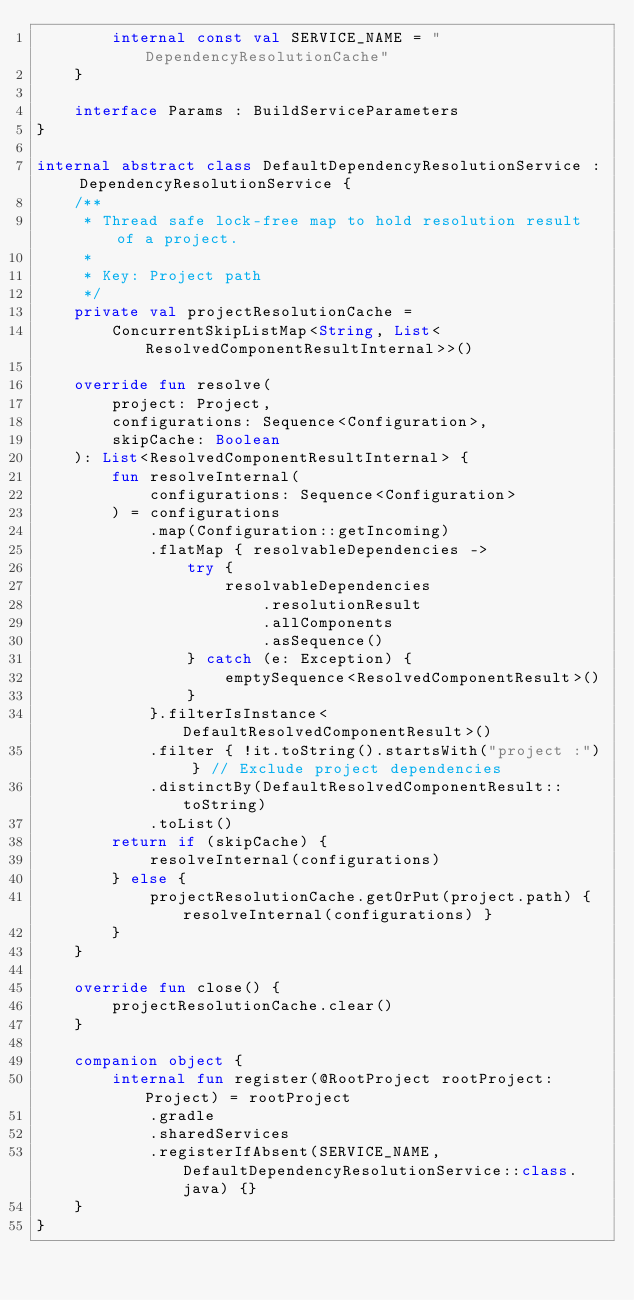<code> <loc_0><loc_0><loc_500><loc_500><_Kotlin_>        internal const val SERVICE_NAME = "DependencyResolutionCache"
    }

    interface Params : BuildServiceParameters
}

internal abstract class DefaultDependencyResolutionService : DependencyResolutionService {
    /**
     * Thread safe lock-free map to hold resolution result of a project.
     *
     * Key: Project path
     */
    private val projectResolutionCache =
        ConcurrentSkipListMap<String, List<ResolvedComponentResultInternal>>()

    override fun resolve(
        project: Project,
        configurations: Sequence<Configuration>,
        skipCache: Boolean
    ): List<ResolvedComponentResultInternal> {
        fun resolveInternal(
            configurations: Sequence<Configuration>
        ) = configurations
            .map(Configuration::getIncoming)
            .flatMap { resolvableDependencies ->
                try {
                    resolvableDependencies
                        .resolutionResult
                        .allComponents
                        .asSequence()
                } catch (e: Exception) {
                    emptySequence<ResolvedComponentResult>()
                }
            }.filterIsInstance<DefaultResolvedComponentResult>()
            .filter { !it.toString().startsWith("project :") } // Exclude project dependencies
            .distinctBy(DefaultResolvedComponentResult::toString)
            .toList()
        return if (skipCache) {
            resolveInternal(configurations)
        } else {
            projectResolutionCache.getOrPut(project.path) { resolveInternal(configurations) }
        }
    }

    override fun close() {
        projectResolutionCache.clear()
    }

    companion object {
        internal fun register(@RootProject rootProject: Project) = rootProject
            .gradle
            .sharedServices
            .registerIfAbsent(SERVICE_NAME, DefaultDependencyResolutionService::class.java) {}
    }
}


</code> 